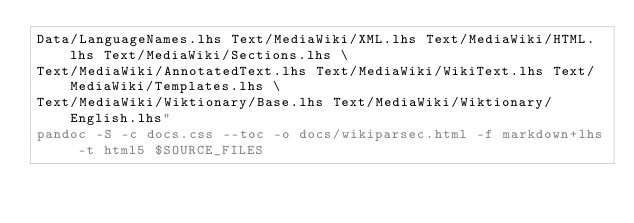Convert code to text. <code><loc_0><loc_0><loc_500><loc_500><_Bash_>Data/LanguageNames.lhs Text/MediaWiki/XML.lhs Text/MediaWiki/HTML.lhs Text/MediaWiki/Sections.lhs \
Text/MediaWiki/AnnotatedText.lhs Text/MediaWiki/WikiText.lhs Text/MediaWiki/Templates.lhs \
Text/MediaWiki/Wiktionary/Base.lhs Text/MediaWiki/Wiktionary/English.lhs"
pandoc -S -c docs.css --toc -o docs/wikiparsec.html -f markdown+lhs -t html5 $SOURCE_FILES
</code> 